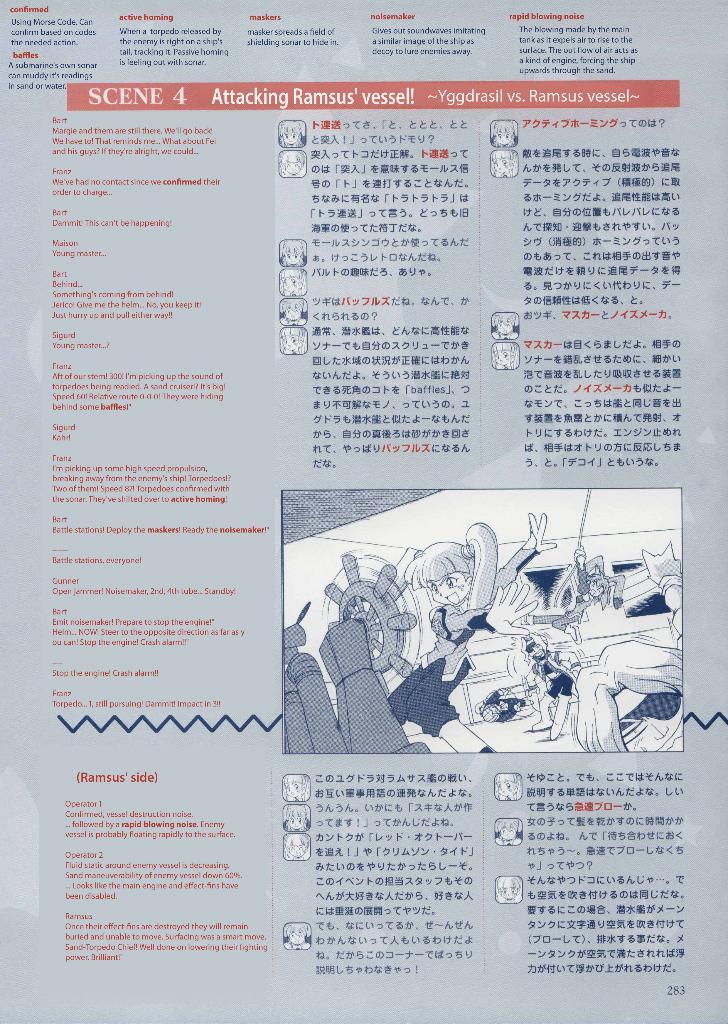What page is this?
Your response must be concise. 283. What scene is this?
Keep it short and to the point. 4. 